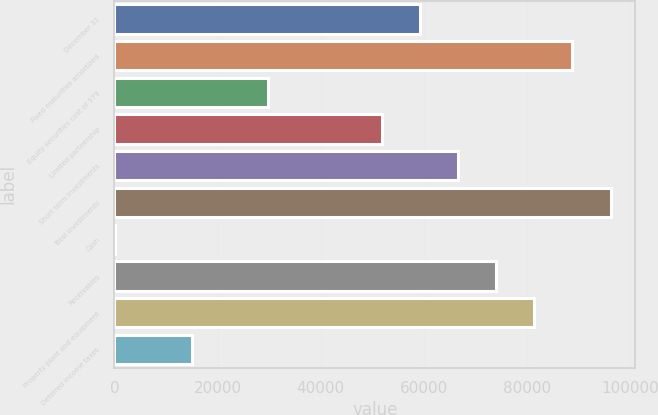<chart> <loc_0><loc_0><loc_500><loc_500><bar_chart><fcel>December 31<fcel>Fixed maturities amortized<fcel>Equity securities cost of 979<fcel>Limited partnership<fcel>Short term investments<fcel>Total investments<fcel>Cash<fcel>Receivables<fcel>Property plant and equipment<fcel>Deferred income taxes<nl><fcel>59294<fcel>88846<fcel>29742<fcel>51906<fcel>66682<fcel>96234<fcel>190<fcel>74070<fcel>81458<fcel>14966<nl></chart> 